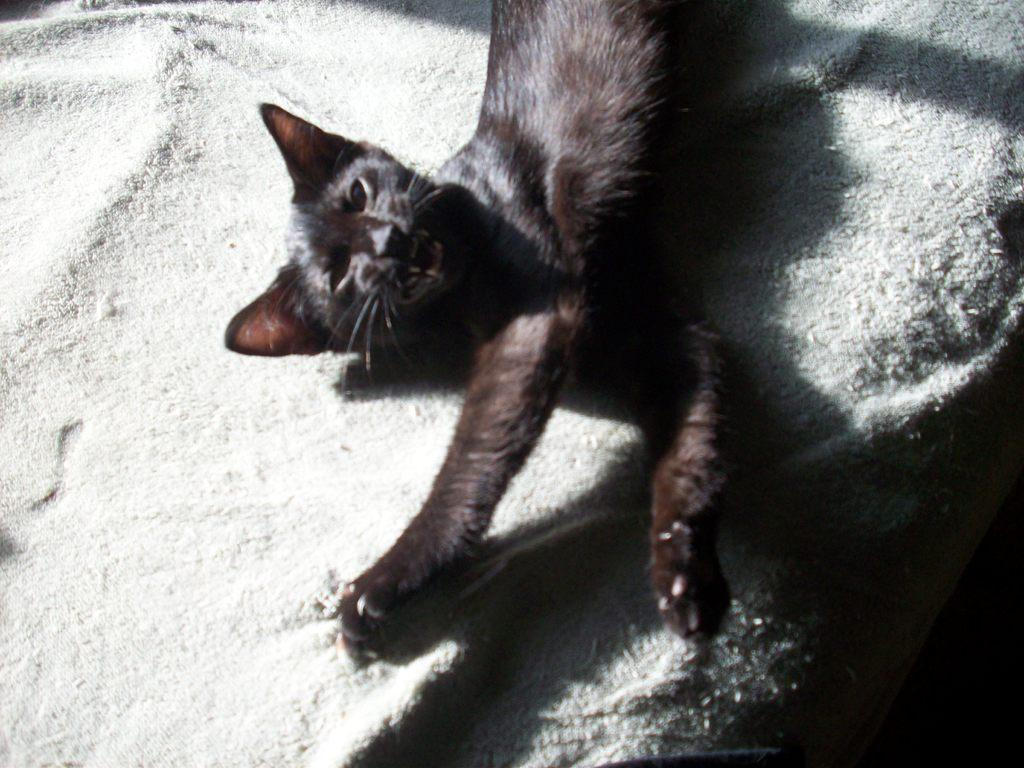What type of animal is in the image? There is a black cat in the image. What color is the surface the cat is on? The cat is on a white surface. Where is the cat located in relation to the image? The cat is in the foreground of the image. What type of cloth is the cat using to cover its partner in the image? There is no cloth or partner present in the image; it features a black cat on a white surface. 